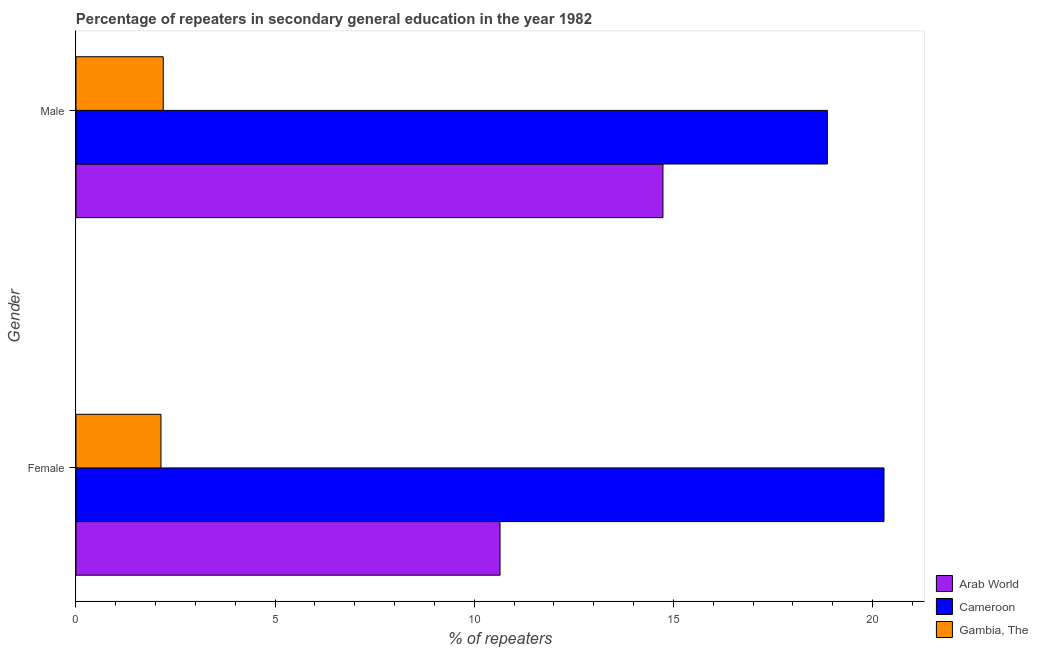How many bars are there on the 1st tick from the top?
Your response must be concise. 3. What is the label of the 2nd group of bars from the top?
Your answer should be compact. Female. What is the percentage of male repeaters in Cameroon?
Your response must be concise. 18.87. Across all countries, what is the maximum percentage of female repeaters?
Your answer should be very brief. 20.29. Across all countries, what is the minimum percentage of male repeaters?
Give a very brief answer. 2.19. In which country was the percentage of male repeaters maximum?
Your answer should be compact. Cameroon. In which country was the percentage of female repeaters minimum?
Offer a very short reply. Gambia, The. What is the total percentage of female repeaters in the graph?
Your answer should be compact. 33.07. What is the difference between the percentage of female repeaters in Gambia, The and that in Cameroon?
Offer a terse response. -18.16. What is the difference between the percentage of male repeaters in Cameroon and the percentage of female repeaters in Gambia, The?
Give a very brief answer. 16.73. What is the average percentage of female repeaters per country?
Keep it short and to the point. 11.02. What is the difference between the percentage of female repeaters and percentage of male repeaters in Cameroon?
Your answer should be very brief. 1.42. In how many countries, is the percentage of female repeaters greater than 5 %?
Your response must be concise. 2. What is the ratio of the percentage of male repeaters in Gambia, The to that in Arab World?
Offer a terse response. 0.15. In how many countries, is the percentage of male repeaters greater than the average percentage of male repeaters taken over all countries?
Make the answer very short. 2. What does the 2nd bar from the top in Female represents?
Provide a short and direct response. Cameroon. What does the 3rd bar from the bottom in Male represents?
Keep it short and to the point. Gambia, The. What is the difference between two consecutive major ticks on the X-axis?
Your answer should be compact. 5. Where does the legend appear in the graph?
Keep it short and to the point. Bottom right. How are the legend labels stacked?
Ensure brevity in your answer.  Vertical. What is the title of the graph?
Make the answer very short. Percentage of repeaters in secondary general education in the year 1982. What is the label or title of the X-axis?
Your answer should be very brief. % of repeaters. What is the label or title of the Y-axis?
Your answer should be very brief. Gender. What is the % of repeaters in Arab World in Female?
Keep it short and to the point. 10.65. What is the % of repeaters of Cameroon in Female?
Your answer should be compact. 20.29. What is the % of repeaters in Gambia, The in Female?
Your answer should be compact. 2.13. What is the % of repeaters of Arab World in Male?
Give a very brief answer. 14.74. What is the % of repeaters in Cameroon in Male?
Your answer should be very brief. 18.87. What is the % of repeaters in Gambia, The in Male?
Your response must be concise. 2.19. Across all Gender, what is the maximum % of repeaters in Arab World?
Keep it short and to the point. 14.74. Across all Gender, what is the maximum % of repeaters of Cameroon?
Your answer should be very brief. 20.29. Across all Gender, what is the maximum % of repeaters in Gambia, The?
Your answer should be compact. 2.19. Across all Gender, what is the minimum % of repeaters in Arab World?
Offer a very short reply. 10.65. Across all Gender, what is the minimum % of repeaters of Cameroon?
Your answer should be very brief. 18.87. Across all Gender, what is the minimum % of repeaters of Gambia, The?
Keep it short and to the point. 2.13. What is the total % of repeaters in Arab World in the graph?
Offer a terse response. 25.39. What is the total % of repeaters of Cameroon in the graph?
Your answer should be compact. 39.16. What is the total % of repeaters of Gambia, The in the graph?
Keep it short and to the point. 4.33. What is the difference between the % of repeaters of Arab World in Female and that in Male?
Give a very brief answer. -4.09. What is the difference between the % of repeaters of Cameroon in Female and that in Male?
Offer a very short reply. 1.42. What is the difference between the % of repeaters in Gambia, The in Female and that in Male?
Give a very brief answer. -0.06. What is the difference between the % of repeaters in Arab World in Female and the % of repeaters in Cameroon in Male?
Give a very brief answer. -8.22. What is the difference between the % of repeaters of Arab World in Female and the % of repeaters of Gambia, The in Male?
Ensure brevity in your answer.  8.46. What is the difference between the % of repeaters of Cameroon in Female and the % of repeaters of Gambia, The in Male?
Offer a very short reply. 18.1. What is the average % of repeaters in Arab World per Gender?
Provide a succinct answer. 12.69. What is the average % of repeaters in Cameroon per Gender?
Your answer should be compact. 19.58. What is the average % of repeaters of Gambia, The per Gender?
Provide a succinct answer. 2.16. What is the difference between the % of repeaters of Arab World and % of repeaters of Cameroon in Female?
Make the answer very short. -9.64. What is the difference between the % of repeaters in Arab World and % of repeaters in Gambia, The in Female?
Your response must be concise. 8.51. What is the difference between the % of repeaters of Cameroon and % of repeaters of Gambia, The in Female?
Give a very brief answer. 18.16. What is the difference between the % of repeaters of Arab World and % of repeaters of Cameroon in Male?
Keep it short and to the point. -4.13. What is the difference between the % of repeaters in Arab World and % of repeaters in Gambia, The in Male?
Your response must be concise. 12.55. What is the difference between the % of repeaters in Cameroon and % of repeaters in Gambia, The in Male?
Provide a succinct answer. 16.68. What is the ratio of the % of repeaters of Arab World in Female to that in Male?
Your answer should be compact. 0.72. What is the ratio of the % of repeaters in Cameroon in Female to that in Male?
Provide a short and direct response. 1.08. What is the ratio of the % of repeaters in Gambia, The in Female to that in Male?
Keep it short and to the point. 0.97. What is the difference between the highest and the second highest % of repeaters of Arab World?
Keep it short and to the point. 4.09. What is the difference between the highest and the second highest % of repeaters in Cameroon?
Your answer should be compact. 1.42. What is the difference between the highest and the second highest % of repeaters of Gambia, The?
Offer a very short reply. 0.06. What is the difference between the highest and the lowest % of repeaters in Arab World?
Provide a short and direct response. 4.09. What is the difference between the highest and the lowest % of repeaters of Cameroon?
Ensure brevity in your answer.  1.42. What is the difference between the highest and the lowest % of repeaters of Gambia, The?
Make the answer very short. 0.06. 